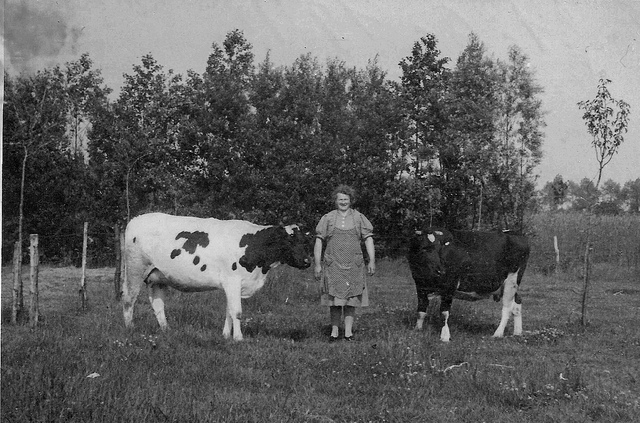<image>What type of shoe is the lady in the dress wearing? I don't know what type of shoe the lady in the dress is wearing. It could be boots, heels, or sneakers. What type of shoe is the lady in the dress wearing? I am not sure what type of shoe the lady in the dress is wearing. It can be seen boots, heels, slide on, dress shoes, sneakers, or high heels. 